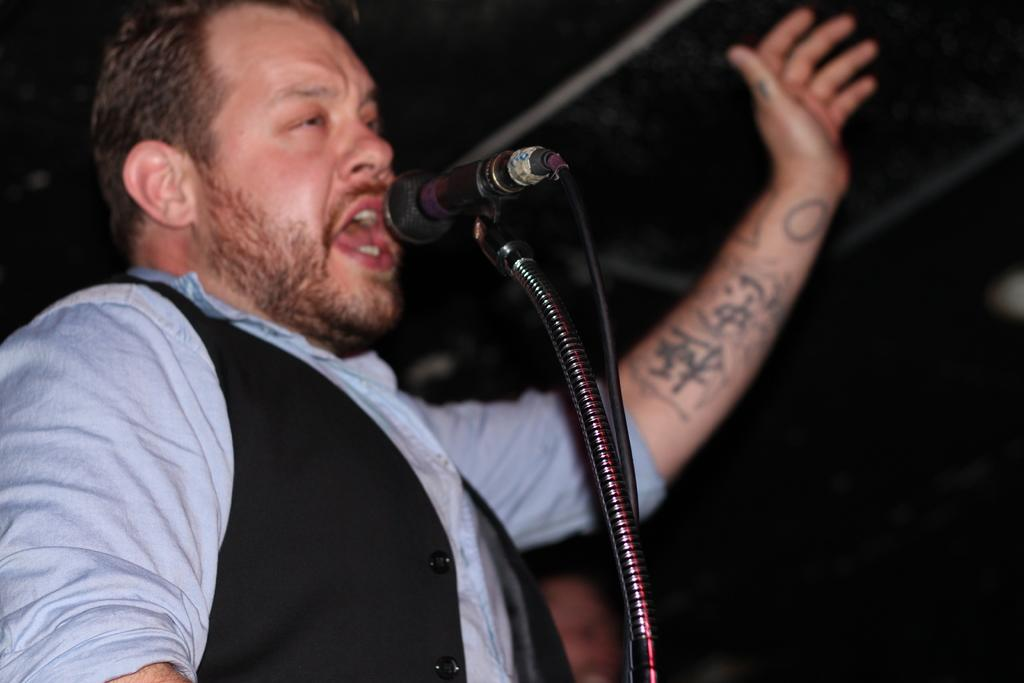Who or what is the main subject of the image? There is a person in the image. What is the person doing in the image? The person is standing in front of a microphone. What can be observed about the person's mouth? The person's mouth is open. What is the color of the background in the image? The background of the image is dark. What type of cake is being judged by the person in the image? There is no cake or judging activity present in the image; the person is standing in front of a microphone with their mouth open. 